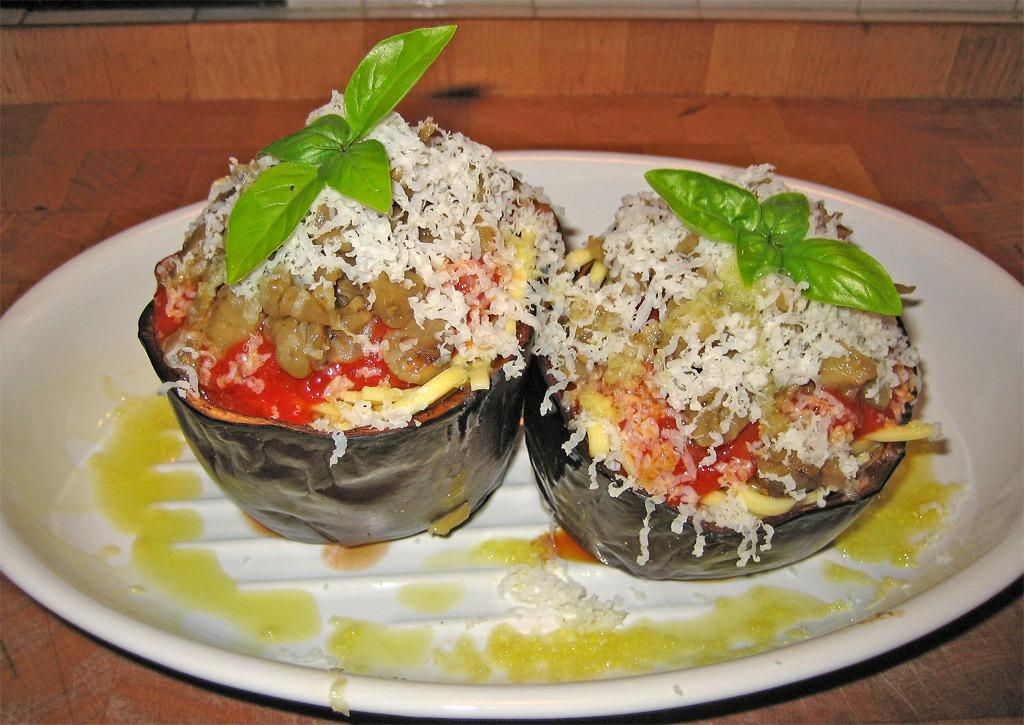What color is the plate in the image? The plate in the image is white. What is the plate resting on? The plate is on a wooden object. What can be found on the plate? There are food items and vegetable leaves on the plate. Can you tell me how the secretary is interacting with the plate in the image? There is no secretary present in the image; it only features a white plate with food items and vegetable leaves. 